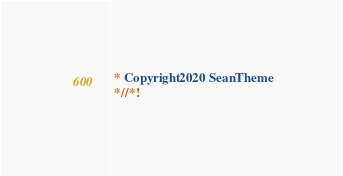<code> <loc_0><loc_0><loc_500><loc_500><_CSS_> * Copyright 2020 SeanTheme
 *//*!</code> 